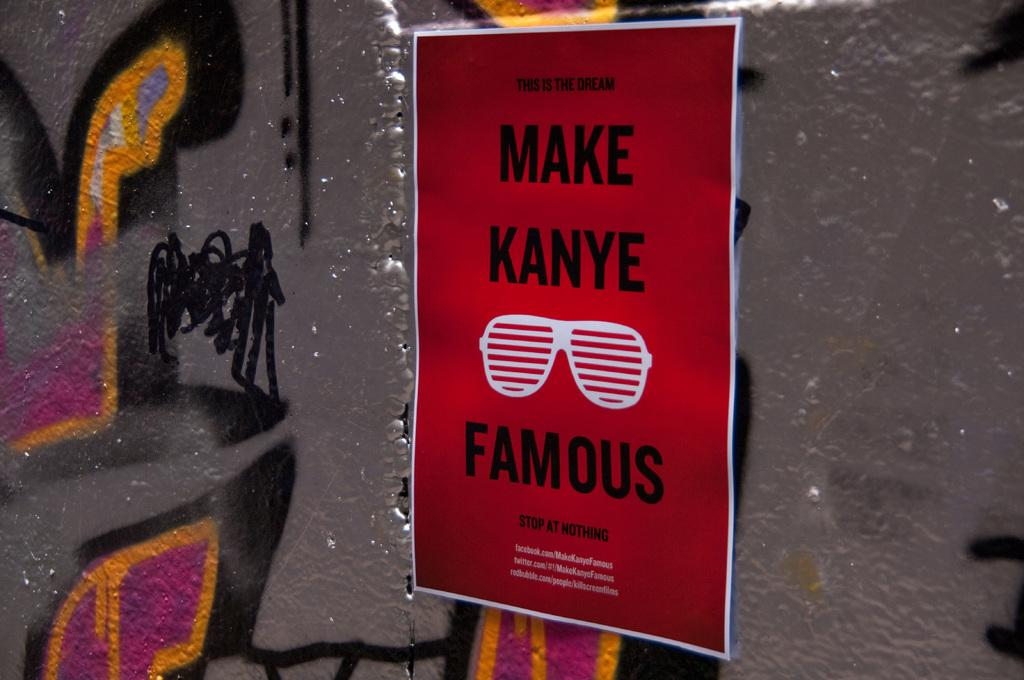<image>
Create a compact narrative representing the image presented. A red Kanye poster with white glasses in the middle section and pasted on a grey wall with graffiti on it. 